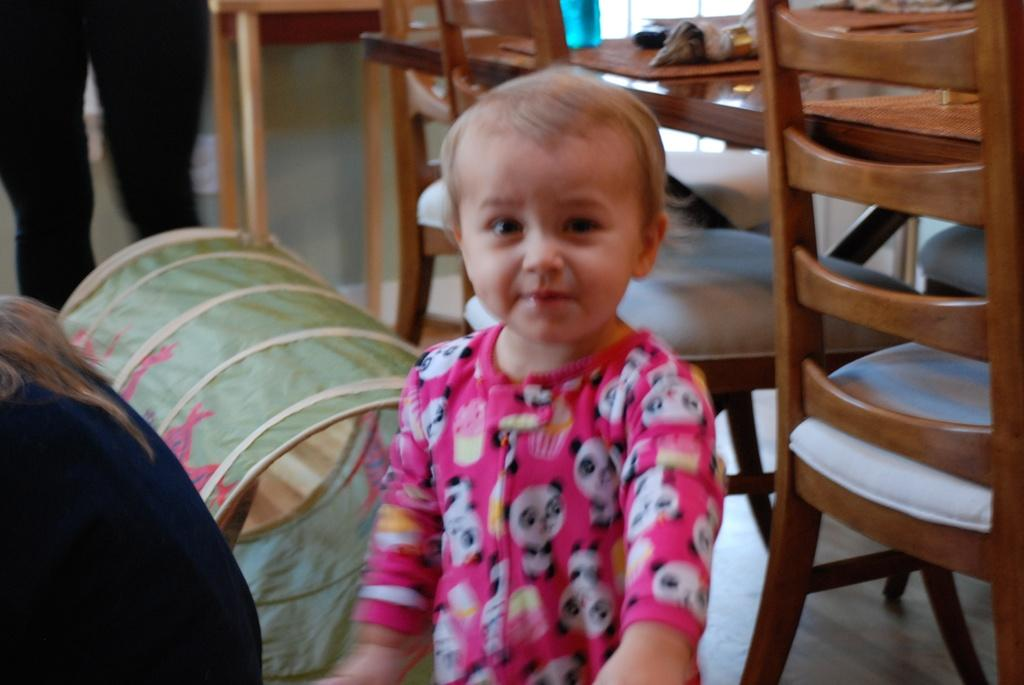What is the main subject in the center of the image? There is a baby in the center of the image. Who is on the left side of the image? There is a person on the left side of the image. Where is the person standing in the image? There is a person standing on the top of the image. What furniture is on the right side of the image? There is a table and chairs on the right side of the image. What object is also on the right side of the image? There is a barrel on the right side of the image. What type of icicle can be seen hanging from the baby's nose in the image? There is no icicle present in the image, and it is not hanging from the baby's nose. 